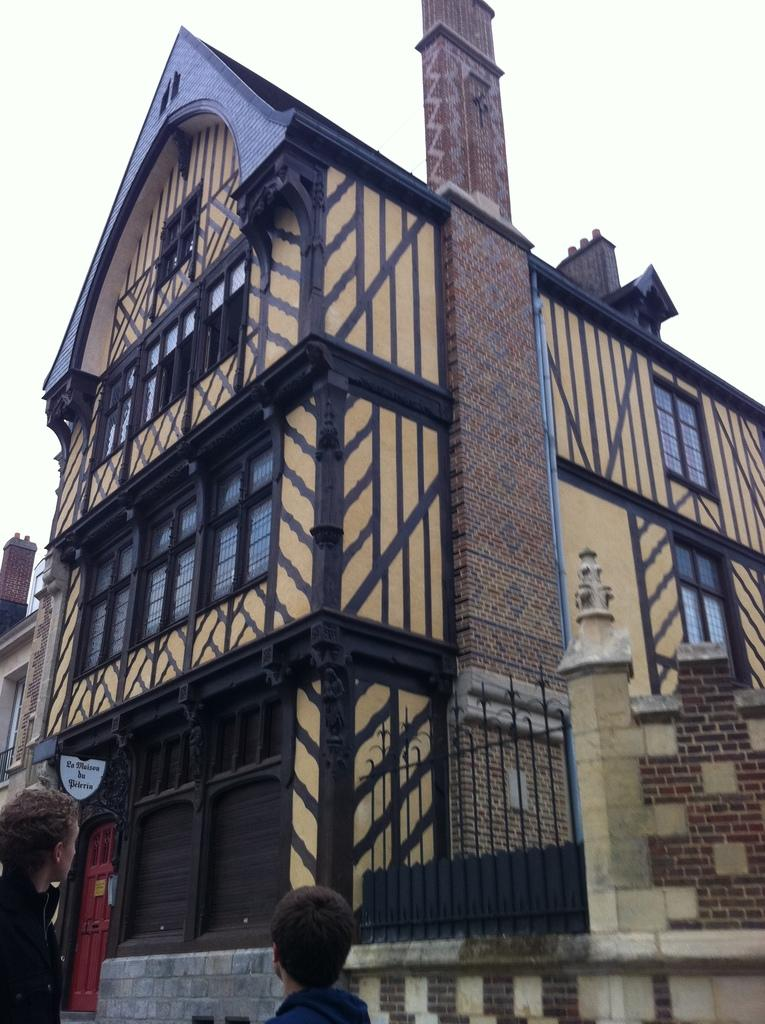What structure is present in the image? There is a building in the image. What part of the natural environment is visible in the image? The sky is visible in the image. How would you describe the sky in the image? The sky appears cloudy in the image. Are there any people present in the image? Yes, there are two people at the bottom of the image. What type of spark can be seen coming from the building in the image? There is no spark visible in the image; it only shows a building with a cloudy sky and two people at the bottom. Can you tell me how many pigs are present in the image? There are no pigs present in the image. 